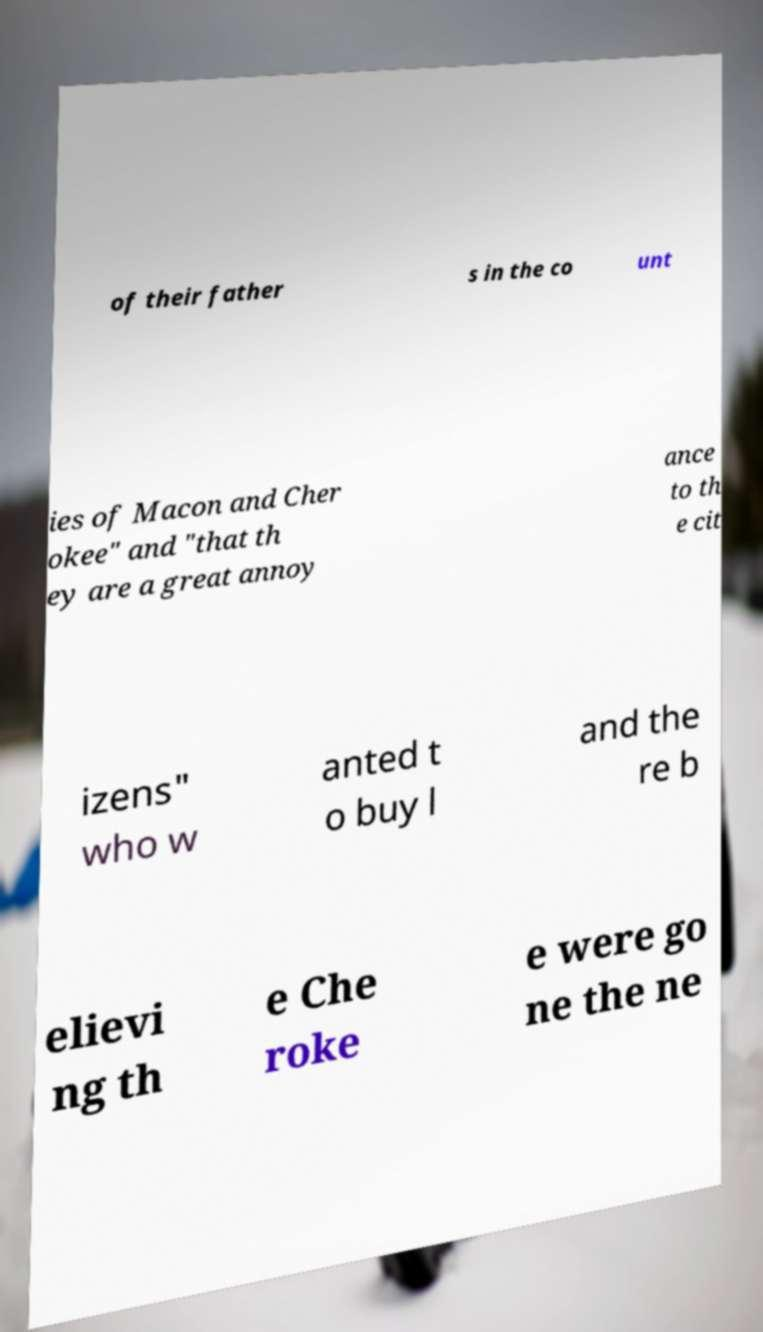Can you accurately transcribe the text from the provided image for me? of their father s in the co unt ies of Macon and Cher okee" and "that th ey are a great annoy ance to th e cit izens" who w anted t o buy l and the re b elievi ng th e Che roke e were go ne the ne 